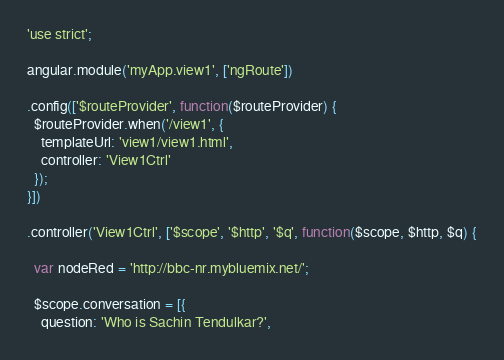Convert code to text. <code><loc_0><loc_0><loc_500><loc_500><_JavaScript_>'use strict';

angular.module('myApp.view1', ['ngRoute'])

.config(['$routeProvider', function($routeProvider) {
  $routeProvider.when('/view1', {
    templateUrl: 'view1/view1.html',
    controller: 'View1Ctrl'
  });
}])

.controller('View1Ctrl', ['$scope', '$http', '$q', function($scope, $http, $q) {

  var nodeRed = 'http://bbc-nr.mybluemix.net/';

  $scope.conversation = [{
    question: 'Who is Sachin Tendulkar?',</code> 